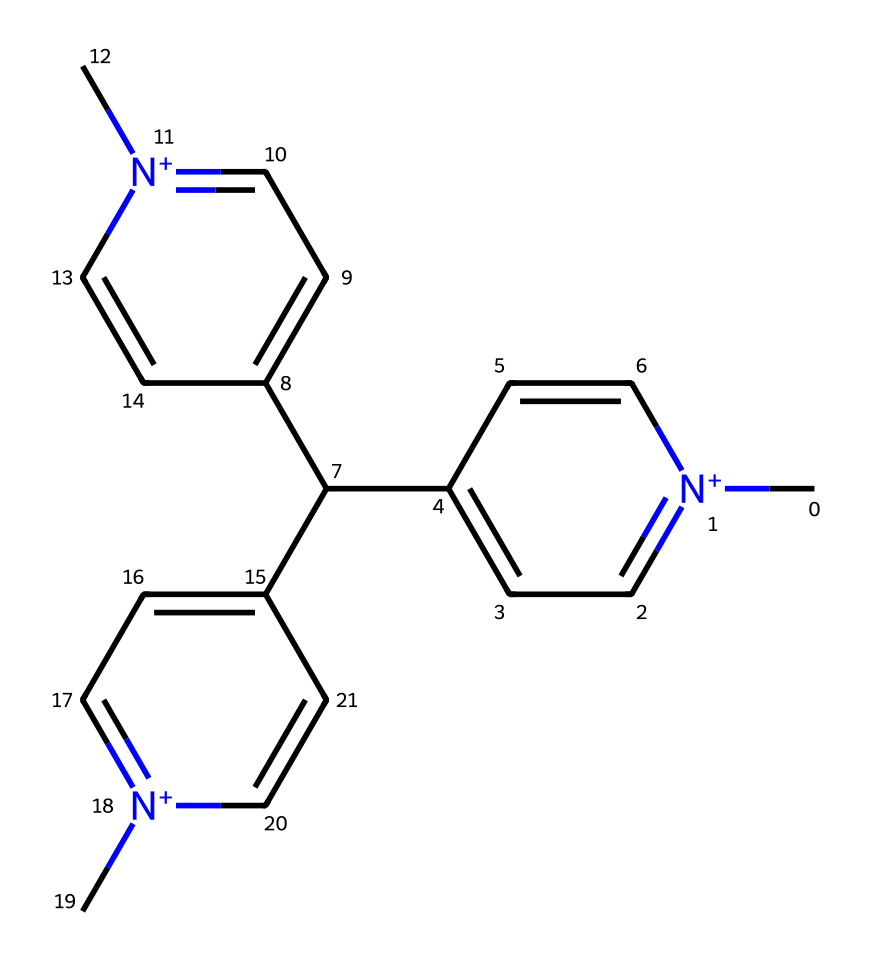What is the total number of nitrogen atoms in this chemical? By examining the SMILES representation, we can identify the nitrogen atoms indicated by the character 'N' and its positive charge '[n+]'. In the structure, there are three occurrences of 'n+' which denote three nitrogen atoms.
Answer: three How many aromatic rings are present in this molecule? The presence of 'c' in the SMILES denotes aromatic carbon atoms. By analyzing the structure, we can discern three aromatic rings present, as indicated by the continuous connected 'c' pattern surrounded by 'N' atoms.
Answer: three What type of chemical structure does paraquat primarily represent? The overall structure, characterized by its nitrogen atoms and aromatic rings, is indicative of an herbicide. This classification is confirmed by its function and structural features.
Answer: herbicide What charge do the nitrogen atoms in this structure carry? The representation contains 'n+' for nitrogen atoms, indicating that these specific atoms carry a positive charge, which is critical for the chemical’s reactivity.
Answer: positive Which functional group is most relevant to the herbicidal activity of paraquat? The presence of the positively charged nitrogen atoms contributes to its interaction with plant systems, directly impacting its herbicidal efficacy.
Answer: nitrogen What element is most abundant in this molecule? Counting the atoms represented by the SMILES, carbon atoms ('C' and 'c') are the most numerous, indicating high carbon content compared to other elements present.
Answer: carbon 